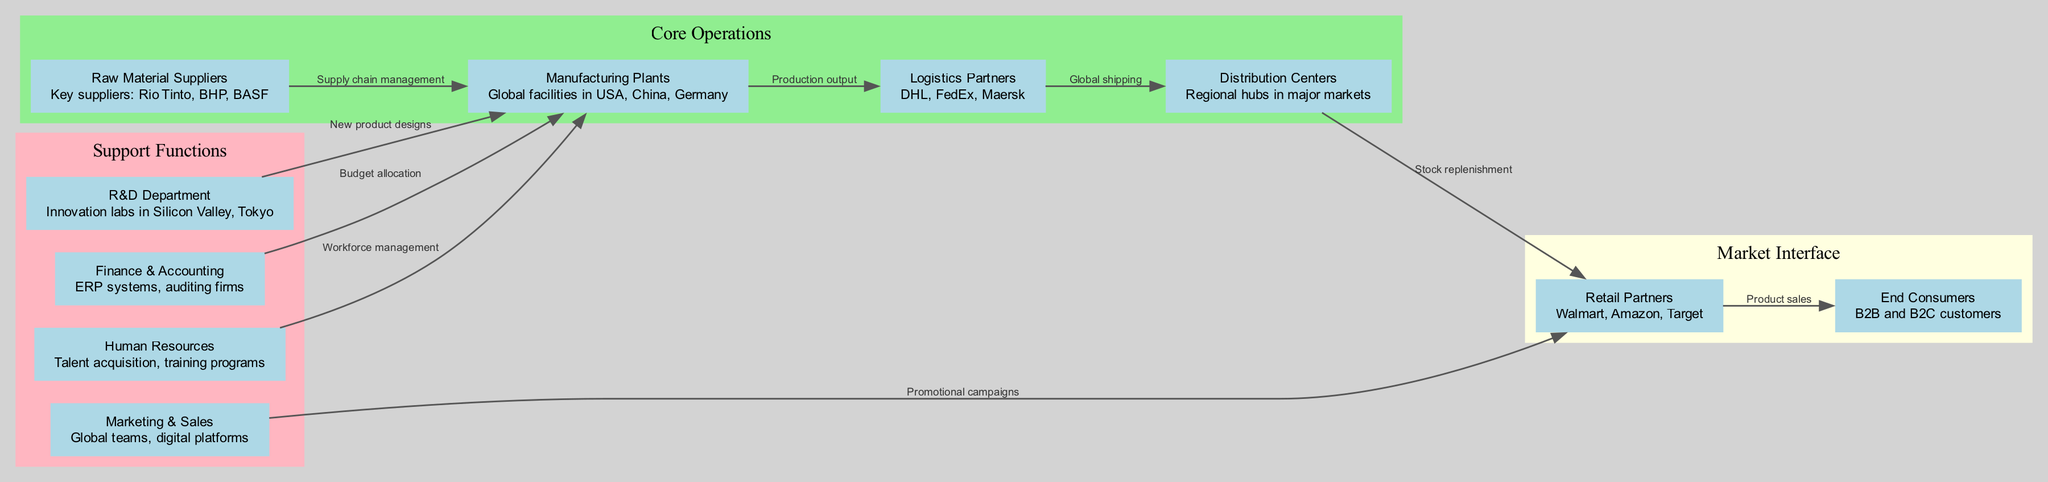What are the key suppliers listed in the diagram? The diagram specifies "Raw Material Suppliers," which include Rio Tinto, BHP, and BASF. To find this information, I examined the 'Raw Material Suppliers' node where the details are explicitly stated.
Answer: Rio Tinto, BHP, BASF How many nodes are present in the value chain analysis? The diagram contains nodes representing various components of the value chain. By counting each unique node listed in the data, I determined there are ten nodes in total.
Answer: 10 Which departments connect to the Manufacturing Plants node? The Manufacturing Plants node has edges leading from the Raw Material Suppliers, R&D Department, Finance & Accounting, and Human Resources nodes. By tracing the edges that originate from Manufacturing, I identified these connections.
Answer: Raw Material Suppliers, R&D Department, Finance & Accounting, Human Resources What process does Logistics Partners contribute to? The Logistics Partners' node contributes to "Global shipping," as indicated on its connecting edge from the Logistics node to the Distribution Centers node. This information can be gathered by examining the labeled edges in the diagram.
Answer: Global shipping Which retailers are mentioned in the diagram? The diagram informs us about the retail partners which include Walmart, Amazon, and Target. I found this data in the 'Retail Partners' node where their names are specifically listed.
Answer: Walmart, Amazon, Target What influence does the R&D Department have on Manufacturing Plants? The R&D Department influences Manufacturing Plants by providing "New product designs," as indicated by the edge that connects these two nodes. Exploring this edge reveals the contribution of R&D to the manufacturing aspect.
Answer: New product designs What is the role of Marketing & Sales in the value chain? Marketing & Sales plays a role in promoting the product through "Promotional campaigns" directed towards Retail Partners, as shown by the corresponding edge connecting these nodes. To understand this role, I observed how Marketing connects to Retailers in the diagram.
Answer: Promotional campaigns How do Distribution Centers connect to Consumers? Distribution Centers connect to Consumers through the "Product sales" process, which is represented by the edge leading from the Retail Partners node to the Consumers node. Analyzing the flow reveals this pathway in the diagram.
Answer: Product sales What are the support functions identified in the diagram? The support functions identified consist of the R&D Department, Marketing & Sales, Finance & Accounting, and Human Resources. By reviewing the nodes grouped under 'Support Functions' in the clusters of the diagram, I compiled these departments.
Answer: R&D Department, Marketing & Sales, Finance & Accounting, Human Resources What is the main output from Manufacturing Plants to Logistics Partners? The main output from Manufacturing Plants to Logistics Partners is the "Production output," as labeled on the edge connecting these two nodes. This output can be quickly found by checking the relationship mentioned on that edge in the diagram.
Answer: Production output 